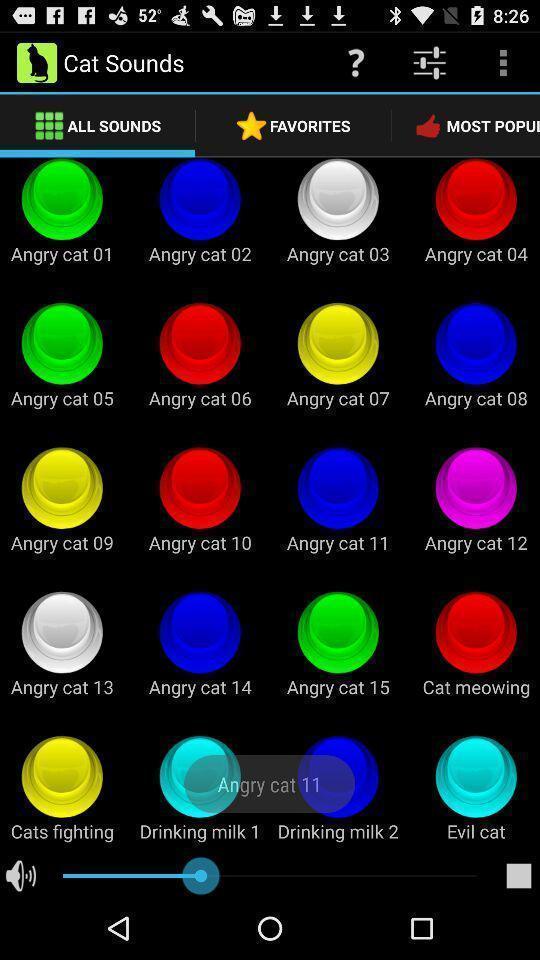Explain the elements present in this screenshot. Page showing list of sounds on music app. 